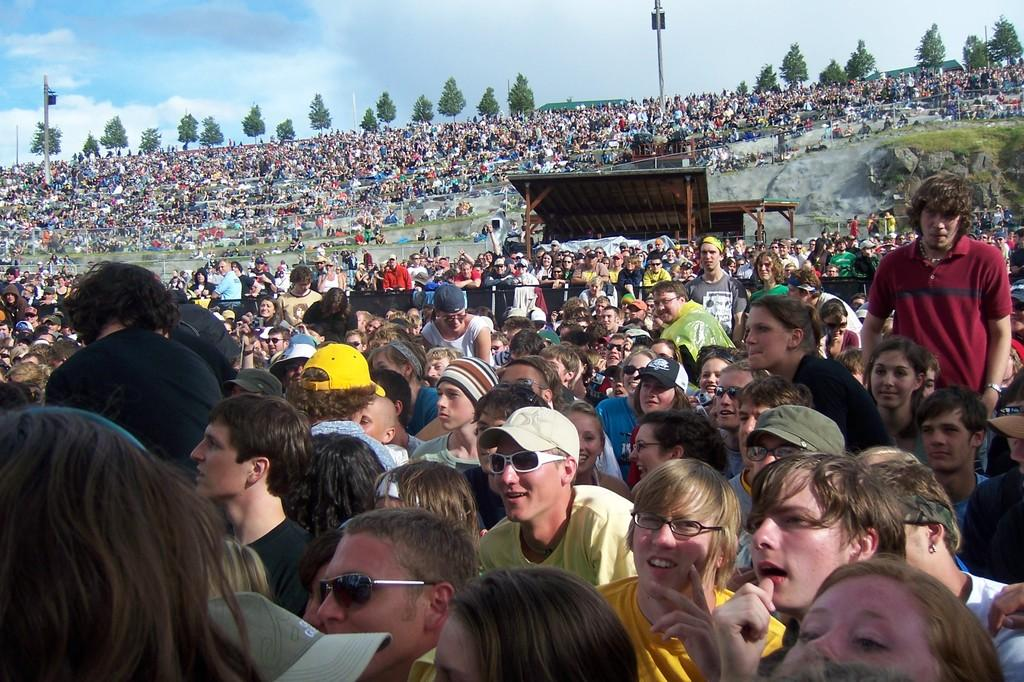What can be seen in the image? There are people, trees, and poles in the image, along with other unspecified objects. Can you describe the people in the image? Unfortunately, the provided facts do not give any details about the people in the image. What type of trees are present in the image? The facts do not specify the type of trees in the image. What are the poles used for in the image? The purpose of the poles in the image is not mentioned in the provided facts. How does the stomach of the person in the image feel? There is no information about the person's stomach or feelings in the image. What question is being asked by the person in the image? The provided facts do not mention any questions being asked in the image. 